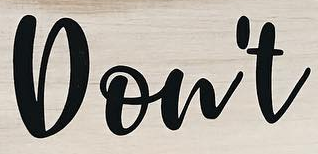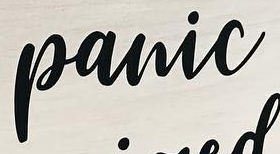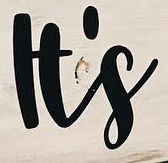What words can you see in these images in sequence, separated by a semicolon? Don't; panic; It's 